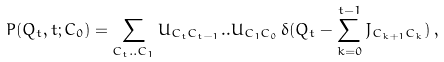Convert formula to latex. <formula><loc_0><loc_0><loc_500><loc_500>P ( Q _ { t } , t ; C _ { 0 } ) = \sum _ { C _ { t } . . C _ { 1 } } U _ { C _ { t } C _ { t - 1 } } . . U _ { C _ { 1 } C _ { 0 } } \, \delta ( Q _ { t } - \sum _ { k = 0 } ^ { t - 1 } J _ { C _ { k + 1 } C _ { k } } ) \, ,</formula> 